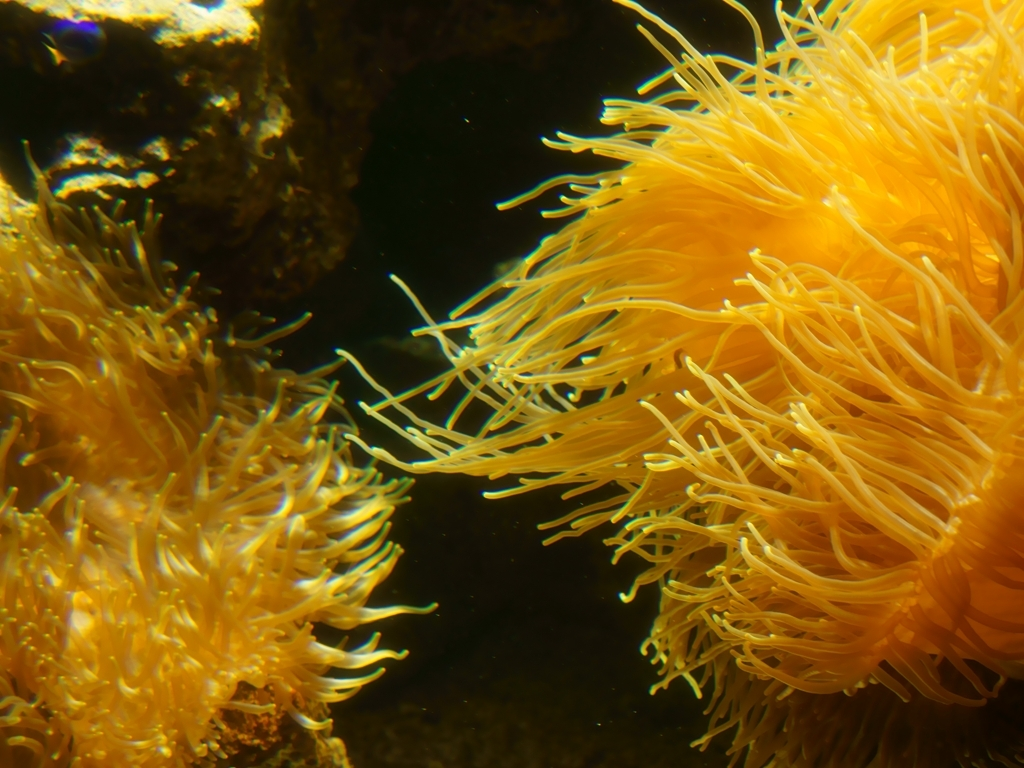Could you explain the role of these organisms in their ecosystem? Certainly! Sea anemones are important as both predators and hosts in the marine environment. They feed on small fish and invertebrates that get ensnared in their tentacles. Additionally, anemones engage in a mutualistic relationship with clownfish, providing them with protection from predators, while the clownfish offer the anemones scraps of their food, thus keeping their habitat clean. 